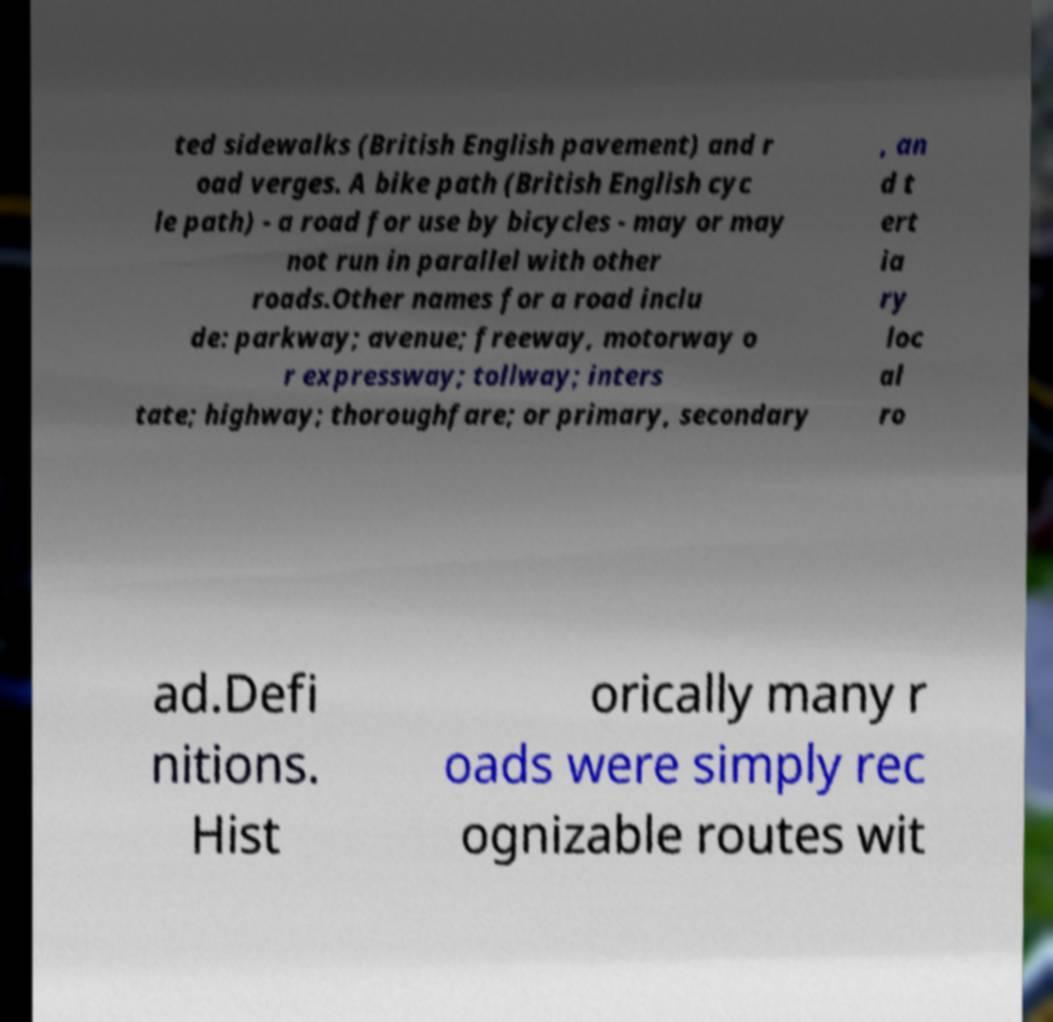Please read and relay the text visible in this image. What does it say? ted sidewalks (British English pavement) and r oad verges. A bike path (British English cyc le path) - a road for use by bicycles - may or may not run in parallel with other roads.Other names for a road inclu de: parkway; avenue; freeway, motorway o r expressway; tollway; inters tate; highway; thoroughfare; or primary, secondary , an d t ert ia ry loc al ro ad.Defi nitions. Hist orically many r oads were simply rec ognizable routes wit 